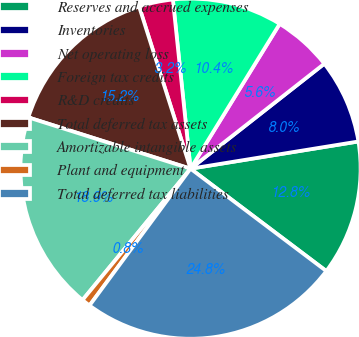Convert chart. <chart><loc_0><loc_0><loc_500><loc_500><pie_chart><fcel>Reserves and accrued expenses<fcel>Inventories<fcel>Net operating loss<fcel>Foreign tax credits<fcel>R&D credits<fcel>Total deferred tax assets<fcel>Amortizable intangible assets<fcel>Plant and equipment<fcel>Total deferred tax liabilities<nl><fcel>12.84%<fcel>8.03%<fcel>5.63%<fcel>10.44%<fcel>3.23%<fcel>15.24%<fcel>18.92%<fcel>0.83%<fcel>24.84%<nl></chart> 